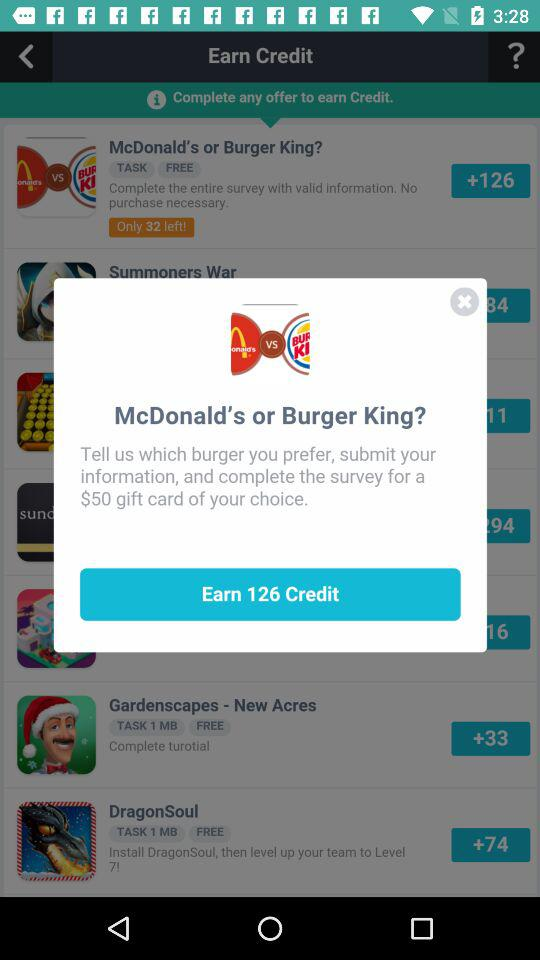How much credit can we earn by completing the survey over "McDonald's or Burger King"? You can earn 126 credit by completing the survey over "McDonald's or Burger King". 